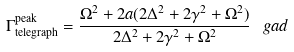<formula> <loc_0><loc_0><loc_500><loc_500>\Gamma _ { \text {telegraph} } ^ { \text {peak} } = \frac { \Omega ^ { 2 } + 2 a ( 2 \Delta ^ { 2 } + 2 \gamma ^ { 2 } + \Omega ^ { 2 } ) } { 2 \Delta ^ { 2 } + 2 \gamma ^ { 2 } + \Omega ^ { 2 } } \, \ g a d</formula> 